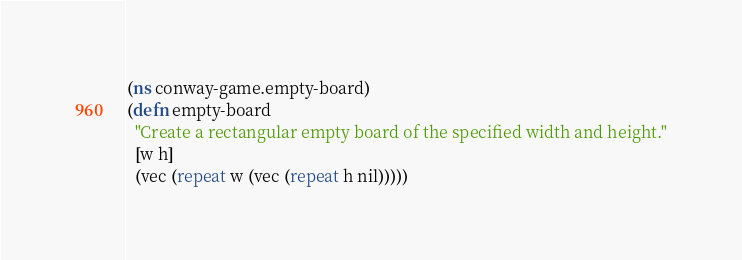Convert code to text. <code><loc_0><loc_0><loc_500><loc_500><_Clojure_>(ns conway-game.empty-board)
(defn empty-board
  "Create a rectangular empty board of the specified width and height."
  [w h]
  (vec (repeat w (vec (repeat h nil)))))
</code> 